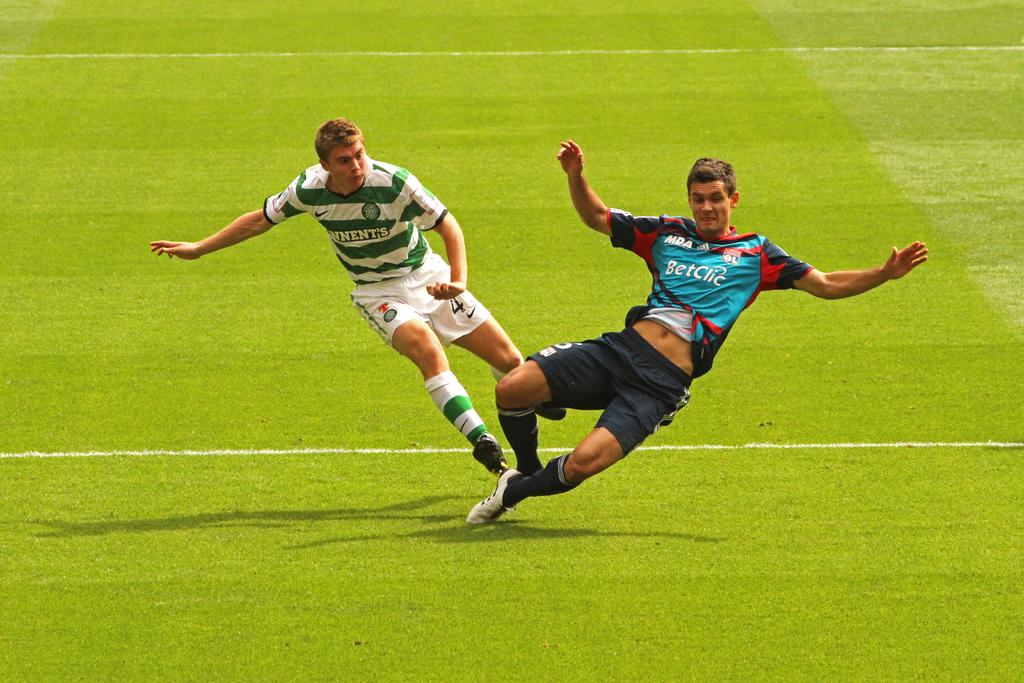How many people are in the image? There are two people in the image. What are the people wearing? The two people are wearing different color dresses. Where are the people located in the image? The two people are on the ground. Are the two people in the image brothers? There is no information provided about the relationship between the two people in the image, so we cannot determine if they are brothers. 